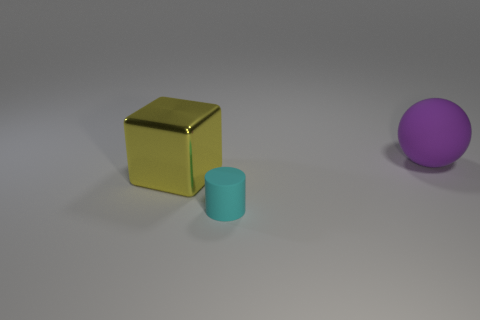Is the cyan cylinder made of the same material as the cube? While the image doesn't provide definitive information about the material of the objects, based on the visual properties such as color, reflectiveness, and texture, it seems that the cyan cylinder and the gold cube are not made of the same material. The cube appears metallic due to its shiny, reflective surface while the cylinder has a matte finish suggesting a different type of material. 